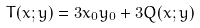Convert formula to latex. <formula><loc_0><loc_0><loc_500><loc_500>T ( x ; y ) = 3 x _ { 0 } y _ { 0 } + 3 Q ( x ; y )</formula> 